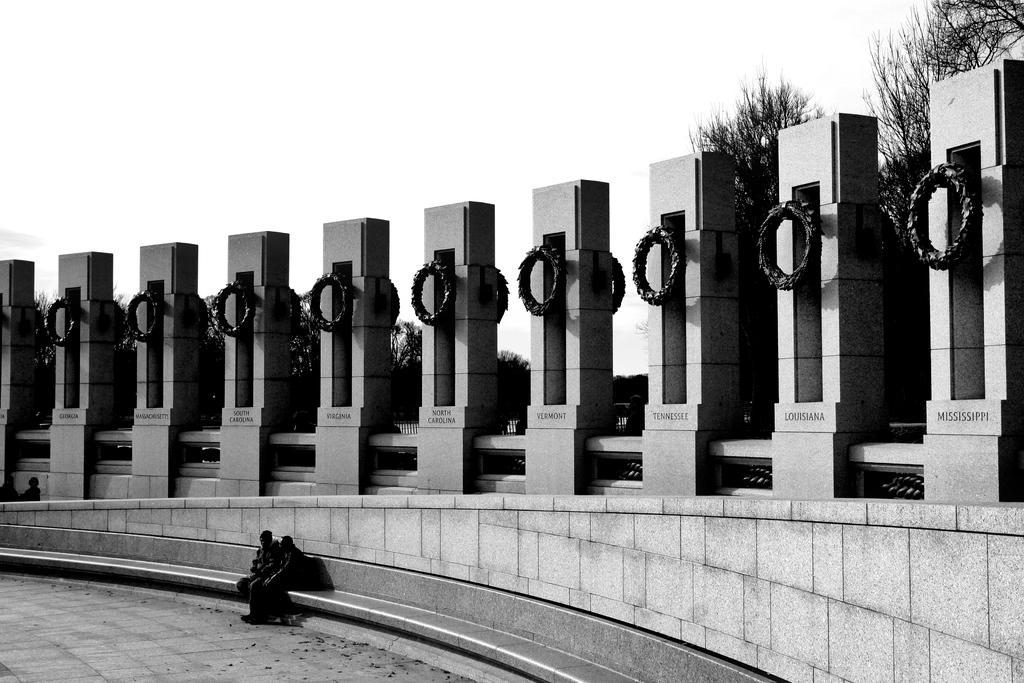Can you describe this image briefly? In this image we can see a black and white image. In the image there are sky, trees, pillars, name boards and persons sitting on the pavement. 